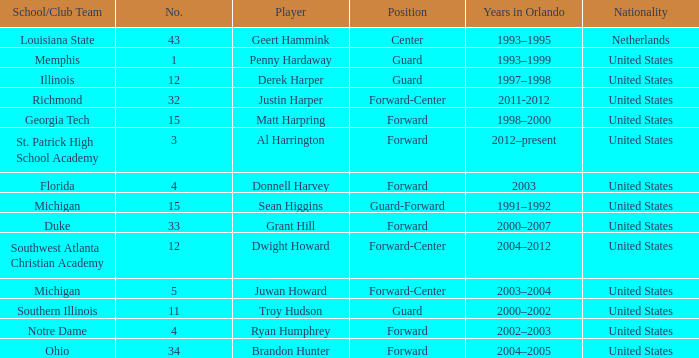What school did Dwight Howard play for Southwest Atlanta Christian Academy. 